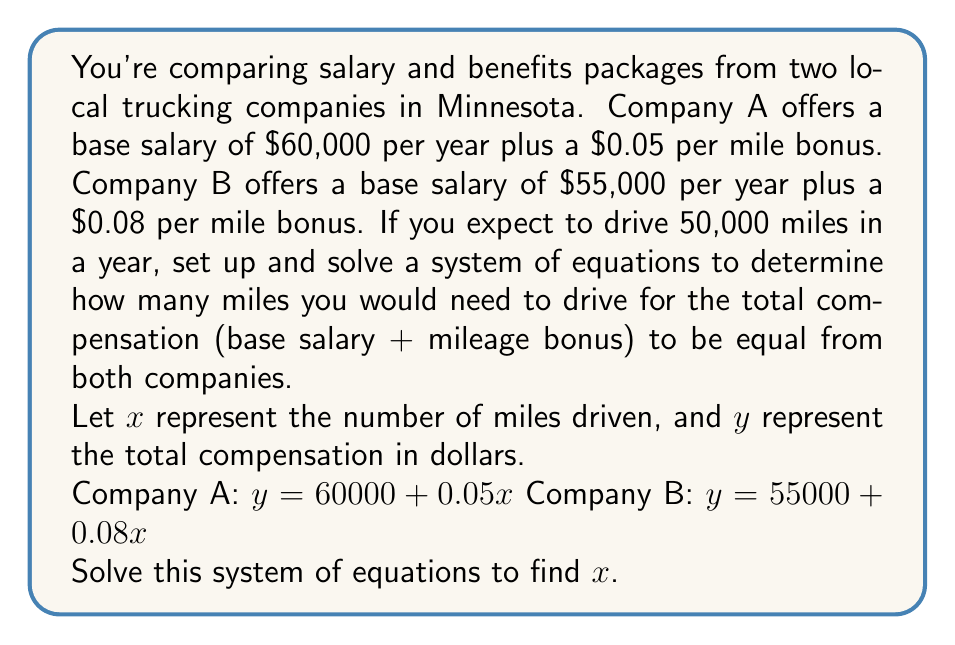Could you help me with this problem? To solve this system of equations, we need to set the two equations equal to each other since we're looking for the point where the total compensation is the same for both companies:

$$60000 + 0.05x = 55000 + 0.08x$$

Now, let's solve for $x$:

1) First, subtract 55000 from both sides:
   $$5000 + 0.05x = 0.08x$$

2) Subtract 0.05x from both sides:
   $$5000 = 0.03x$$

3) Divide both sides by 0.03:
   $$\frac{5000}{0.03} = x$$

4) Simplify:
   $$166,666.67 = x$$

Since we can't drive a fractional mile, we'll round to the nearest whole number:

$$x = 166,667 \text{ miles}$$

To verify, let's calculate the total compensation for both companies at this mileage:

Company A: $60000 + (0.05 * 166667) = 60000 + 8333.35 = 68,333.35$
Company B: $55000 + (0.08 * 166667) = 55000 + 13333.36 = 68,333.36$

The slight difference is due to rounding, but this confirms our solution.

Given that you expect to drive 50,000 miles in a year, which is significantly less than the breakeven point of 166,667 miles, Company A's offer would provide higher total compensation for your expected mileage.
Answer: You would need to drive 166,667 miles for the total compensation to be equal from both companies. At your expected 50,000 miles per year, Company A's offer would provide higher total compensation. 